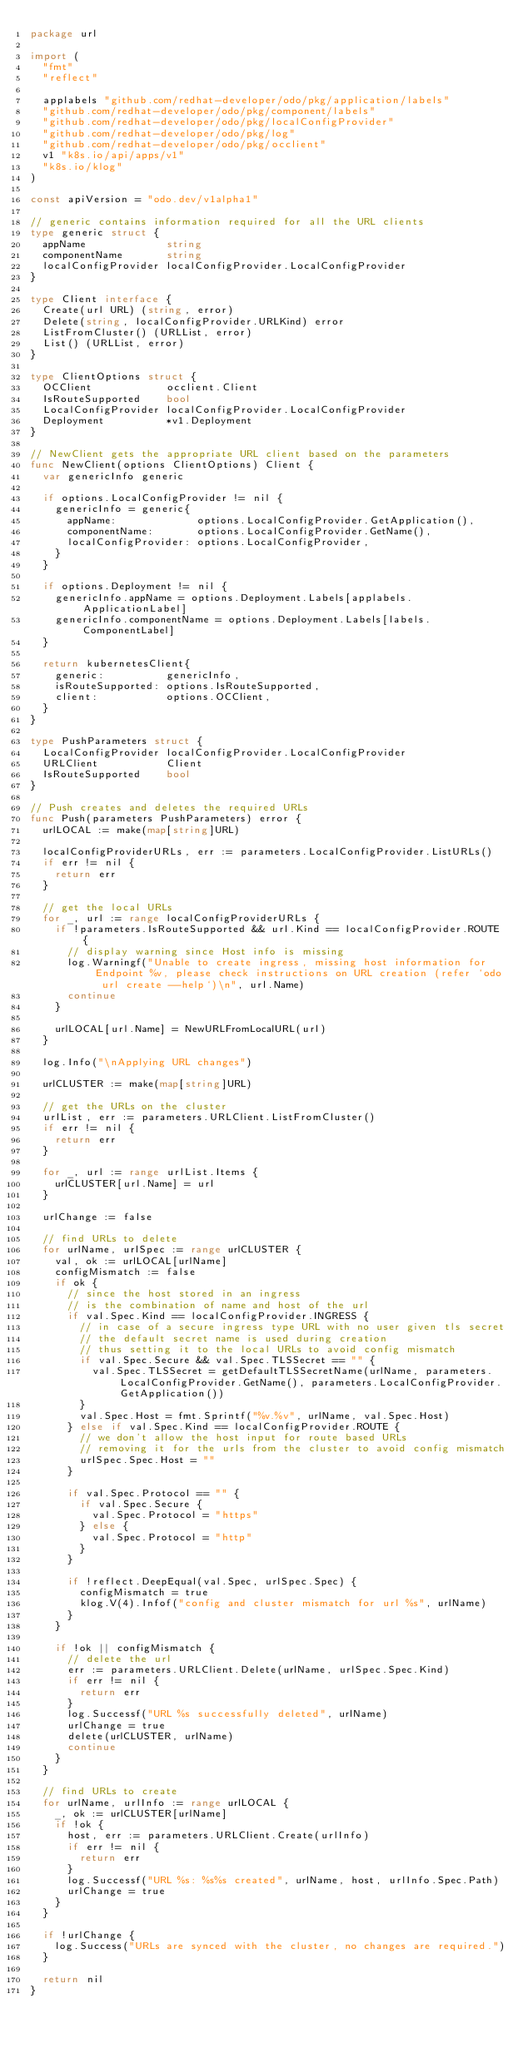<code> <loc_0><loc_0><loc_500><loc_500><_Go_>package url

import (
	"fmt"
	"reflect"

	applabels "github.com/redhat-developer/odo/pkg/application/labels"
	"github.com/redhat-developer/odo/pkg/component/labels"
	"github.com/redhat-developer/odo/pkg/localConfigProvider"
	"github.com/redhat-developer/odo/pkg/log"
	"github.com/redhat-developer/odo/pkg/occlient"
	v1 "k8s.io/api/apps/v1"
	"k8s.io/klog"
)

const apiVersion = "odo.dev/v1alpha1"

// generic contains information required for all the URL clients
type generic struct {
	appName             string
	componentName       string
	localConfigProvider localConfigProvider.LocalConfigProvider
}

type Client interface {
	Create(url URL) (string, error)
	Delete(string, localConfigProvider.URLKind) error
	ListFromCluster() (URLList, error)
	List() (URLList, error)
}

type ClientOptions struct {
	OCClient            occlient.Client
	IsRouteSupported    bool
	LocalConfigProvider localConfigProvider.LocalConfigProvider
	Deployment          *v1.Deployment
}

// NewClient gets the appropriate URL client based on the parameters
func NewClient(options ClientOptions) Client {
	var genericInfo generic

	if options.LocalConfigProvider != nil {
		genericInfo = generic{
			appName:             options.LocalConfigProvider.GetApplication(),
			componentName:       options.LocalConfigProvider.GetName(),
			localConfigProvider: options.LocalConfigProvider,
		}
	}

	if options.Deployment != nil {
		genericInfo.appName = options.Deployment.Labels[applabels.ApplicationLabel]
		genericInfo.componentName = options.Deployment.Labels[labels.ComponentLabel]
	}

	return kubernetesClient{
		generic:          genericInfo,
		isRouteSupported: options.IsRouteSupported,
		client:           options.OCClient,
	}
}

type PushParameters struct {
	LocalConfigProvider localConfigProvider.LocalConfigProvider
	URLClient           Client
	IsRouteSupported    bool
}

// Push creates and deletes the required URLs
func Push(parameters PushParameters) error {
	urlLOCAL := make(map[string]URL)

	localConfigProviderURLs, err := parameters.LocalConfigProvider.ListURLs()
	if err != nil {
		return err
	}

	// get the local URLs
	for _, url := range localConfigProviderURLs {
		if !parameters.IsRouteSupported && url.Kind == localConfigProvider.ROUTE {
			// display warning since Host info is missing
			log.Warningf("Unable to create ingress, missing host information for Endpoint %v, please check instructions on URL creation (refer `odo url create --help`)\n", url.Name)
			continue
		}

		urlLOCAL[url.Name] = NewURLFromLocalURL(url)
	}

	log.Info("\nApplying URL changes")

	urlCLUSTER := make(map[string]URL)

	// get the URLs on the cluster
	urlList, err := parameters.URLClient.ListFromCluster()
	if err != nil {
		return err
	}

	for _, url := range urlList.Items {
		urlCLUSTER[url.Name] = url
	}

	urlChange := false

	// find URLs to delete
	for urlName, urlSpec := range urlCLUSTER {
		val, ok := urlLOCAL[urlName]
		configMismatch := false
		if ok {
			// since the host stored in an ingress
			// is the combination of name and host of the url
			if val.Spec.Kind == localConfigProvider.INGRESS {
				// in case of a secure ingress type URL with no user given tls secret
				// the default secret name is used during creation
				// thus setting it to the local URLs to avoid config mismatch
				if val.Spec.Secure && val.Spec.TLSSecret == "" {
					val.Spec.TLSSecret = getDefaultTLSSecretName(urlName, parameters.LocalConfigProvider.GetName(), parameters.LocalConfigProvider.GetApplication())
				}
				val.Spec.Host = fmt.Sprintf("%v.%v", urlName, val.Spec.Host)
			} else if val.Spec.Kind == localConfigProvider.ROUTE {
				// we don't allow the host input for route based URLs
				// removing it for the urls from the cluster to avoid config mismatch
				urlSpec.Spec.Host = ""
			}

			if val.Spec.Protocol == "" {
				if val.Spec.Secure {
					val.Spec.Protocol = "https"
				} else {
					val.Spec.Protocol = "http"
				}
			}

			if !reflect.DeepEqual(val.Spec, urlSpec.Spec) {
				configMismatch = true
				klog.V(4).Infof("config and cluster mismatch for url %s", urlName)
			}
		}

		if !ok || configMismatch {
			// delete the url
			err := parameters.URLClient.Delete(urlName, urlSpec.Spec.Kind)
			if err != nil {
				return err
			}
			log.Successf("URL %s successfully deleted", urlName)
			urlChange = true
			delete(urlCLUSTER, urlName)
			continue
		}
	}

	// find URLs to create
	for urlName, urlInfo := range urlLOCAL {
		_, ok := urlCLUSTER[urlName]
		if !ok {
			host, err := parameters.URLClient.Create(urlInfo)
			if err != nil {
				return err
			}
			log.Successf("URL %s: %s%s created", urlName, host, urlInfo.Spec.Path)
			urlChange = true
		}
	}

	if !urlChange {
		log.Success("URLs are synced with the cluster, no changes are required.")
	}

	return nil
}
</code> 